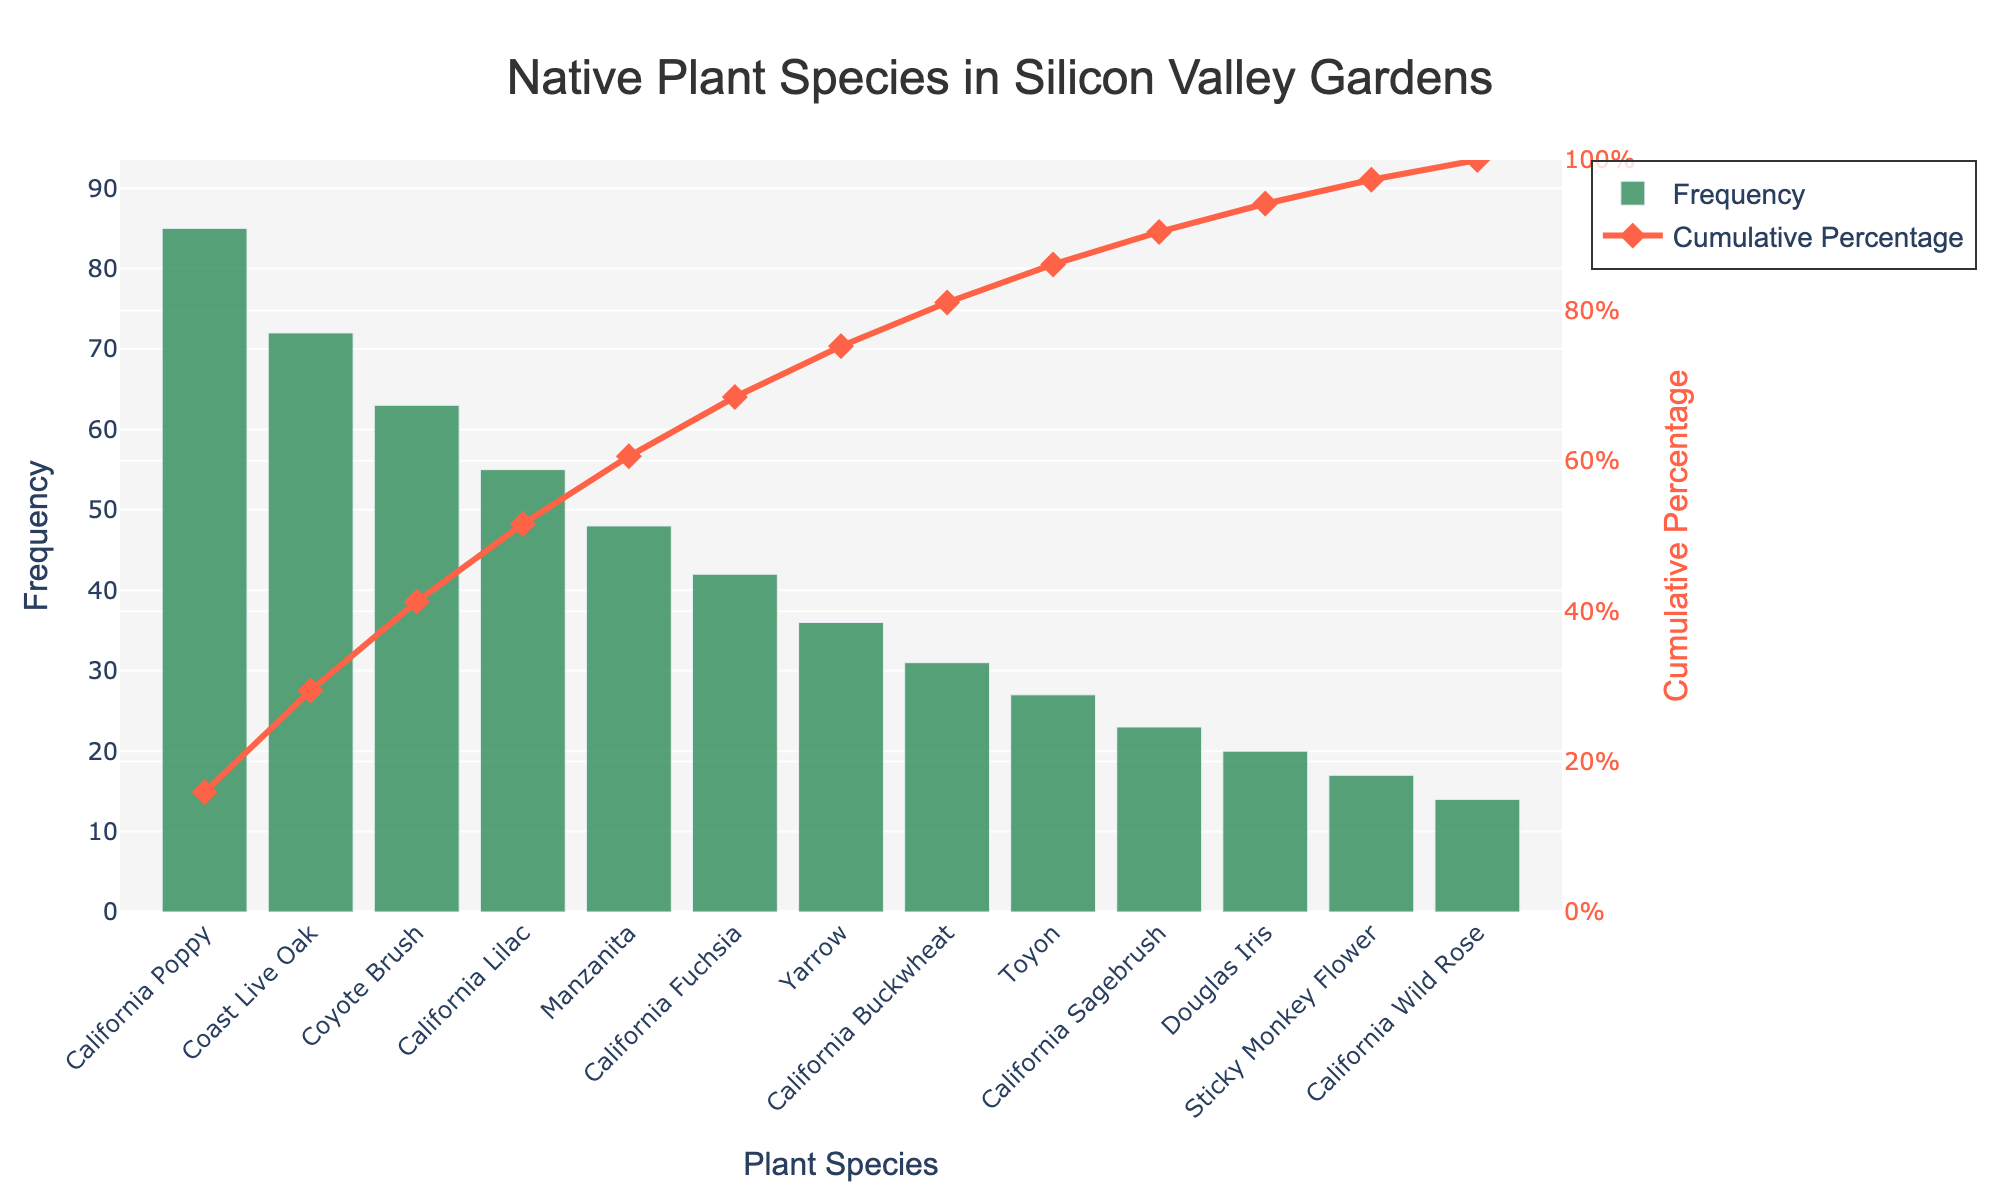How many plant species are represented in the figure? Count the number of distinct plant species listed on the X-axis.
Answer: 13 Which plant species has the highest frequency of occurrence? Identify the plant species with the tallest bar in the chart.
Answer: California Poppy What is the cumulative percentage after adding California Poppy and Coast Live Oak? Find the cumulative percentage at Coast Live Oak, which includes California Poppy.
Answer: 39.8% Which plant species reaches the cumulative 50% mark? Identify the plant species where the cumulative line crosses the halfway (50%) mark on the right Y-axis.
Answer: Coyote Brush What is the frequency difference between California Poppy and California Lilac? Subtract the frequency of California Lilac from the frequency of California Poppy.
Answer: 30 Which species has a higher frequency: Yarrow or California Buckwheat? Compare the heights of the bars representing Yarrow and California Buckwheat to see which is taller.
Answer: Yarrow What is the cumulative percentage covered by the top 3 most frequent plant species? Sum the cumulative percentages up to the third species from the left.
Answer: 55.2% How many species contribute to the last 25% of the cumulative percentage? Count the number of species from the rightmost part of the cumulative line until it reaches 75% on the right Y-axis.
Answer: 6 Which type of plot is used to display the cumulative percentage? Identify the plot type based on the symbols and line style for the cumulative percentage.
Answer: Line chart What color represents the frequency bars, and what color represents the cumulative percentage line? Identify the colors used for the frequency bars and cumulative percentage line from the plot.
Answer: Frequency bars: green; Cumulative percentage line: red 